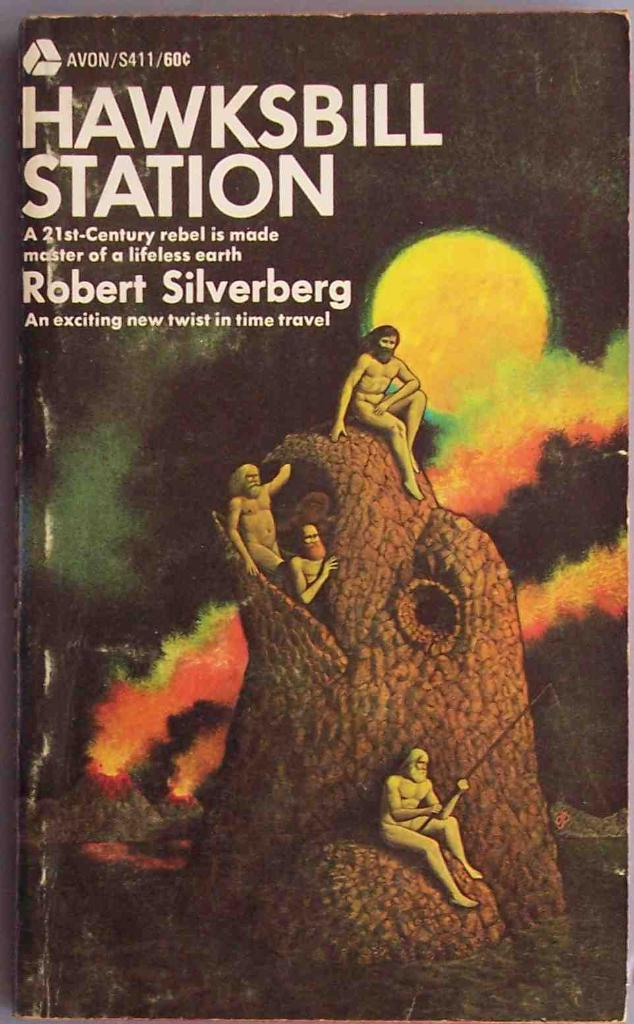Provide a one-sentence caption for the provided image. a book cover written by robert silverberg with naked men sitting on a large tree fishing. 